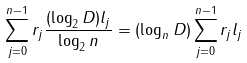Convert formula to latex. <formula><loc_0><loc_0><loc_500><loc_500>\sum _ { j = 0 } ^ { n - 1 } r _ { j } \frac { ( \log _ { 2 } D ) l _ { j } } { \log _ { 2 } n } = \left ( \log _ { n } D \right ) \sum _ { j = 0 } ^ { n - 1 } r _ { j } l _ { j }</formula> 